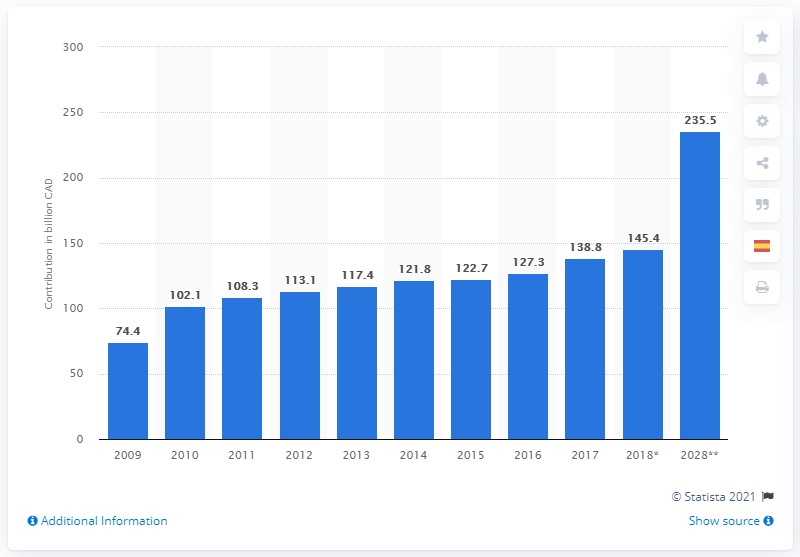List a handful of essential elements in this visual. According to projections, travel and tourism is expected to contribute significantly to the Canadian economy in 2028, with an estimated contribution of 235.5.. 